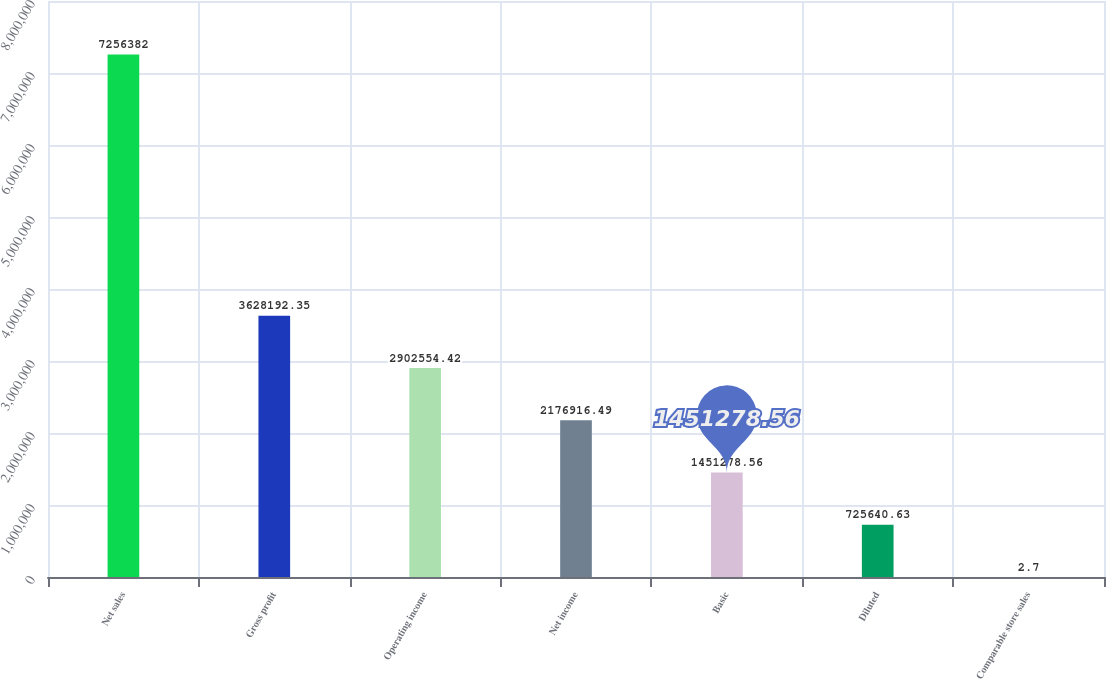<chart> <loc_0><loc_0><loc_500><loc_500><bar_chart><fcel>Net sales<fcel>Gross profit<fcel>Operating income<fcel>Net income<fcel>Basic<fcel>Diluted<fcel>Comparable store sales<nl><fcel>7.25638e+06<fcel>3.62819e+06<fcel>2.90255e+06<fcel>2.17692e+06<fcel>1.45128e+06<fcel>725641<fcel>2.7<nl></chart> 